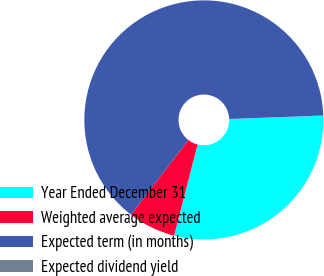Convert chart to OTSL. <chart><loc_0><loc_0><loc_500><loc_500><pie_chart><fcel>Year Ended December 31<fcel>Weighted average expected<fcel>Expected term (in months)<fcel>Expected dividend yield<nl><fcel>29.56%<fcel>6.43%<fcel>63.99%<fcel>0.03%<nl></chart> 